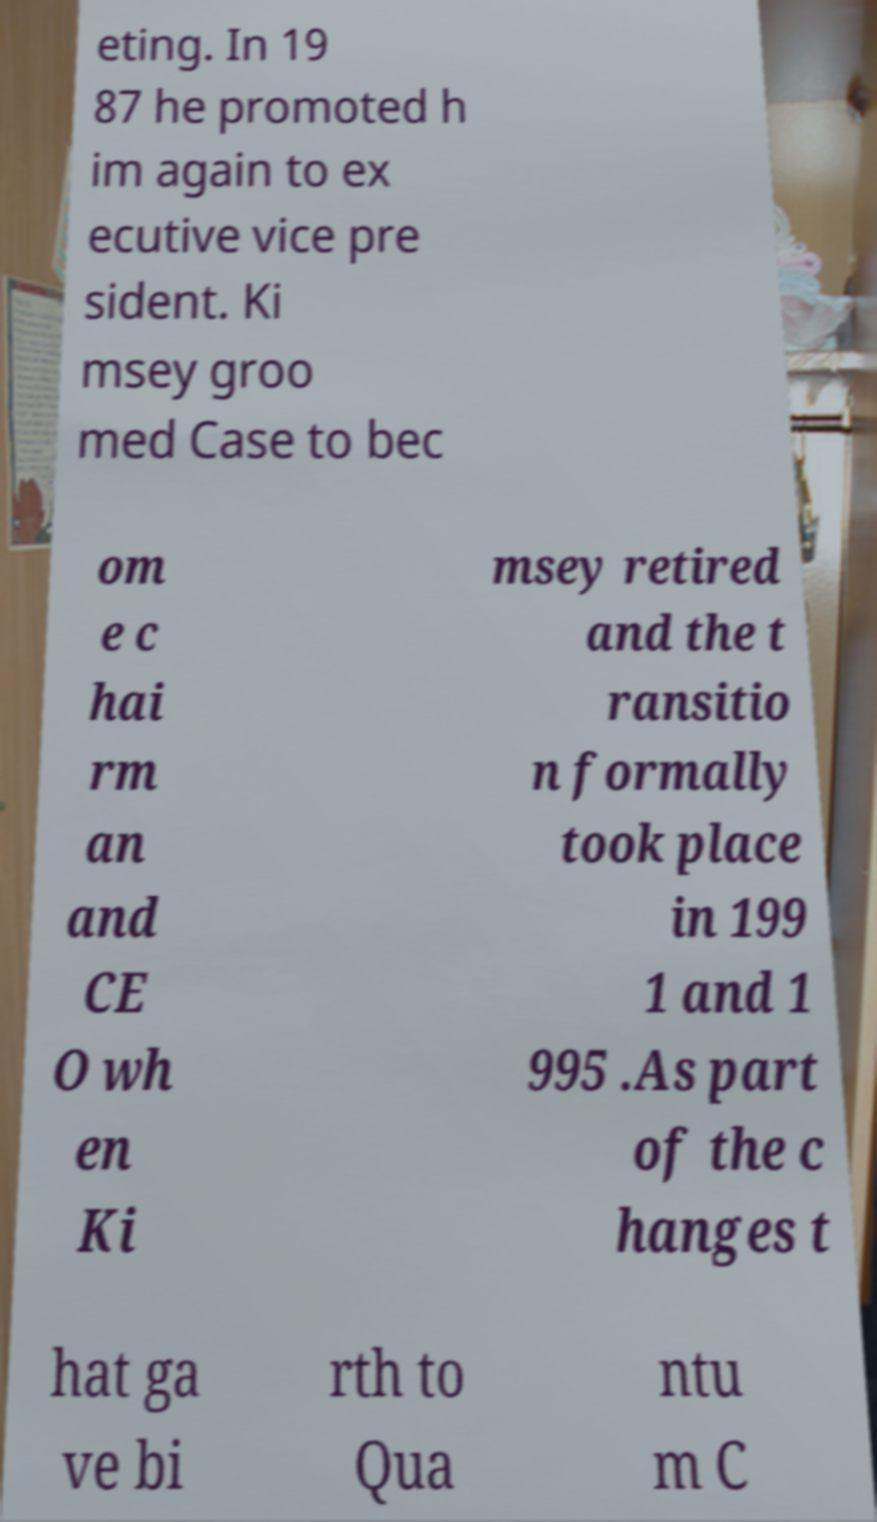Can you accurately transcribe the text from the provided image for me? eting. In 19 87 he promoted h im again to ex ecutive vice pre sident. Ki msey groo med Case to bec om e c hai rm an and CE O wh en Ki msey retired and the t ransitio n formally took place in 199 1 and 1 995 .As part of the c hanges t hat ga ve bi rth to Qua ntu m C 